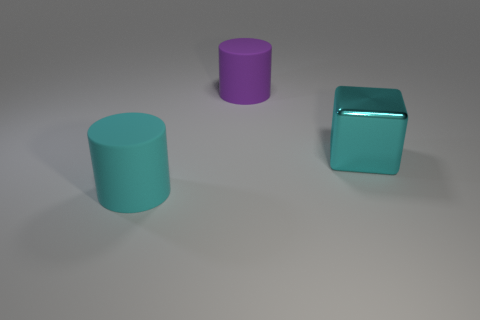Add 3 large cyan rubber cylinders. How many objects exist? 6 Subtract all purple cylinders. How many cylinders are left? 1 Subtract 2 cylinders. How many cylinders are left? 0 Subtract all blocks. How many objects are left? 2 Subtract all yellow cubes. Subtract all gray spheres. How many cubes are left? 1 Subtract all gray cylinders. How many purple cubes are left? 0 Subtract all large objects. Subtract all blue shiny blocks. How many objects are left? 0 Add 3 purple things. How many purple things are left? 4 Add 2 large cyan objects. How many large cyan objects exist? 4 Subtract 1 purple cylinders. How many objects are left? 2 